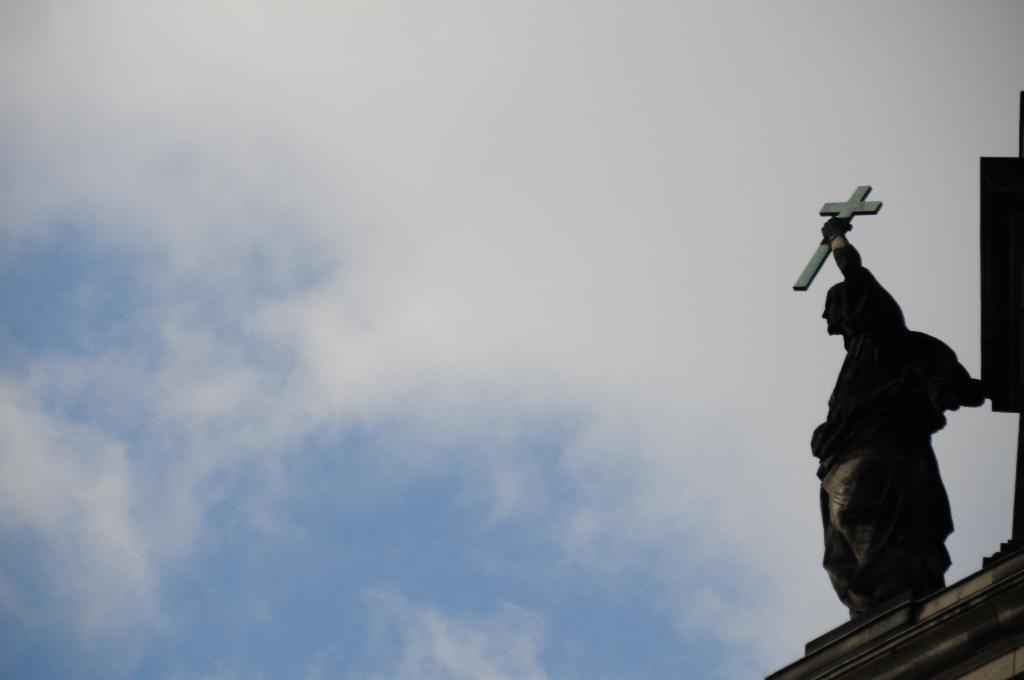Describe this image in one or two sentences. In this image I can see a statue of a man. In the background I can see the sky. 